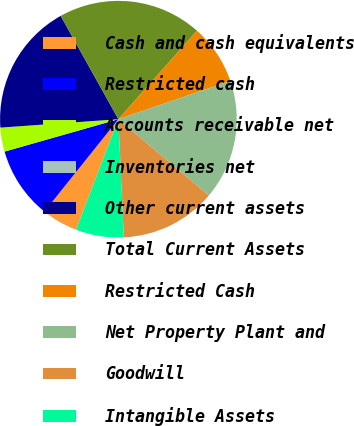Convert chart to OTSL. <chart><loc_0><loc_0><loc_500><loc_500><pie_chart><fcel>Cash and cash equivalents<fcel>Restricted cash<fcel>Accounts receivable net<fcel>Inventories net<fcel>Other current assets<fcel>Total Current Assets<fcel>Restricted Cash<fcel>Net Property Plant and<fcel>Goodwill<fcel>Intangible Assets<nl><fcel>4.92%<fcel>9.84%<fcel>3.28%<fcel>0.0%<fcel>18.03%<fcel>19.67%<fcel>8.2%<fcel>16.39%<fcel>13.11%<fcel>6.56%<nl></chart> 